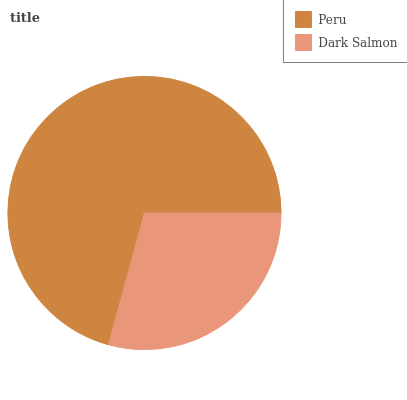Is Dark Salmon the minimum?
Answer yes or no. Yes. Is Peru the maximum?
Answer yes or no. Yes. Is Dark Salmon the maximum?
Answer yes or no. No. Is Peru greater than Dark Salmon?
Answer yes or no. Yes. Is Dark Salmon less than Peru?
Answer yes or no. Yes. Is Dark Salmon greater than Peru?
Answer yes or no. No. Is Peru less than Dark Salmon?
Answer yes or no. No. Is Peru the high median?
Answer yes or no. Yes. Is Dark Salmon the low median?
Answer yes or no. Yes. Is Dark Salmon the high median?
Answer yes or no. No. Is Peru the low median?
Answer yes or no. No. 